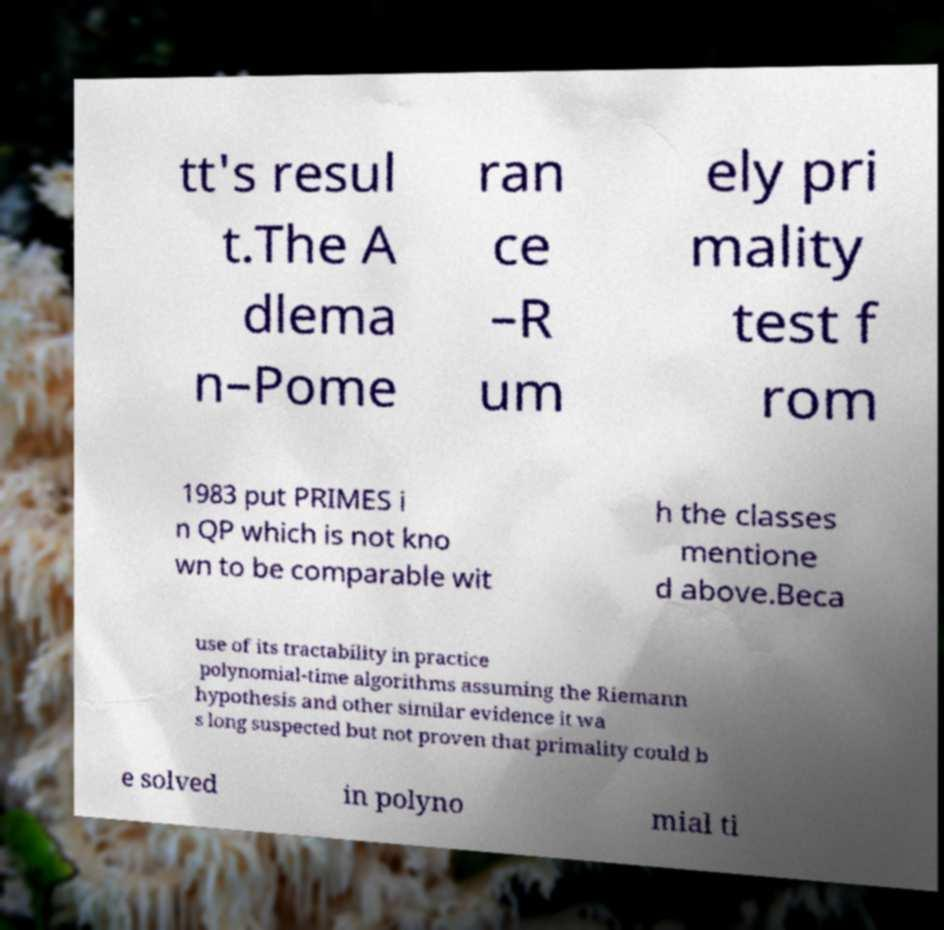Could you extract and type out the text from this image? tt's resul t.The A dlema n–Pome ran ce –R um ely pri mality test f rom 1983 put PRIMES i n QP which is not kno wn to be comparable wit h the classes mentione d above.Beca use of its tractability in practice polynomial-time algorithms assuming the Riemann hypothesis and other similar evidence it wa s long suspected but not proven that primality could b e solved in polyno mial ti 